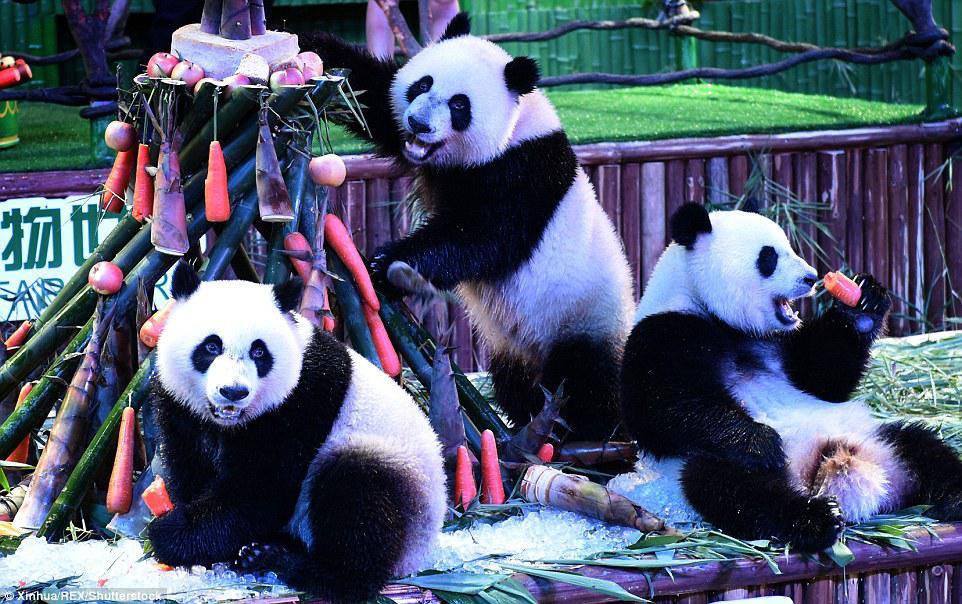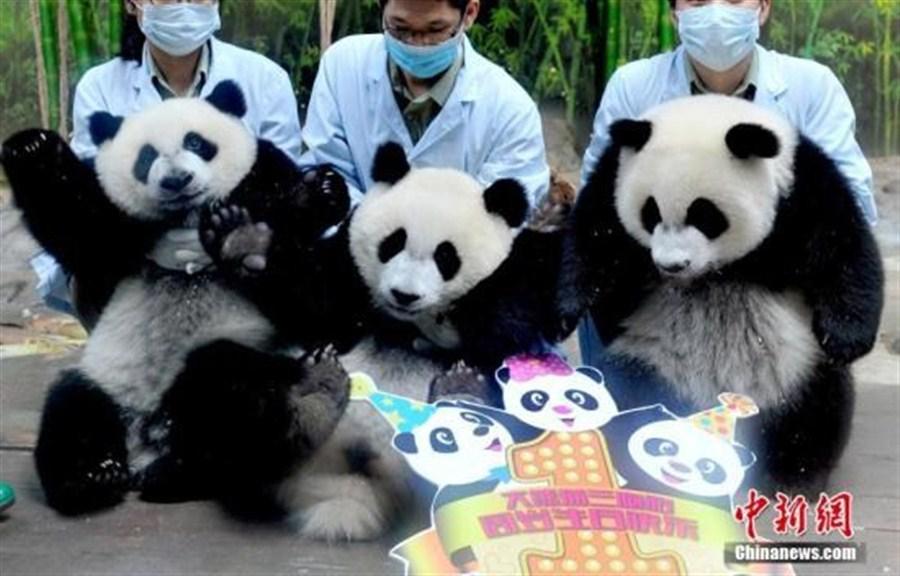The first image is the image on the left, the second image is the image on the right. Given the left and right images, does the statement "An image shows at least one person in protective gear behind a panda, grasping it" hold true? Answer yes or no. Yes. 